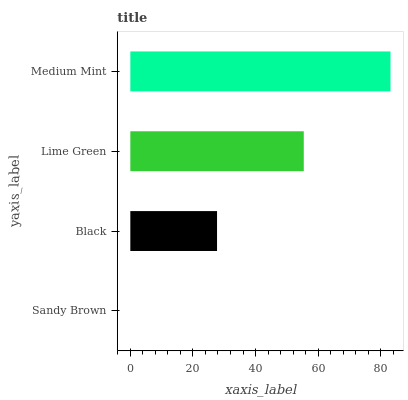Is Sandy Brown the minimum?
Answer yes or no. Yes. Is Medium Mint the maximum?
Answer yes or no. Yes. Is Black the minimum?
Answer yes or no. No. Is Black the maximum?
Answer yes or no. No. Is Black greater than Sandy Brown?
Answer yes or no. Yes. Is Sandy Brown less than Black?
Answer yes or no. Yes. Is Sandy Brown greater than Black?
Answer yes or no. No. Is Black less than Sandy Brown?
Answer yes or no. No. Is Lime Green the high median?
Answer yes or no. Yes. Is Black the low median?
Answer yes or no. Yes. Is Medium Mint the high median?
Answer yes or no. No. Is Medium Mint the low median?
Answer yes or no. No. 